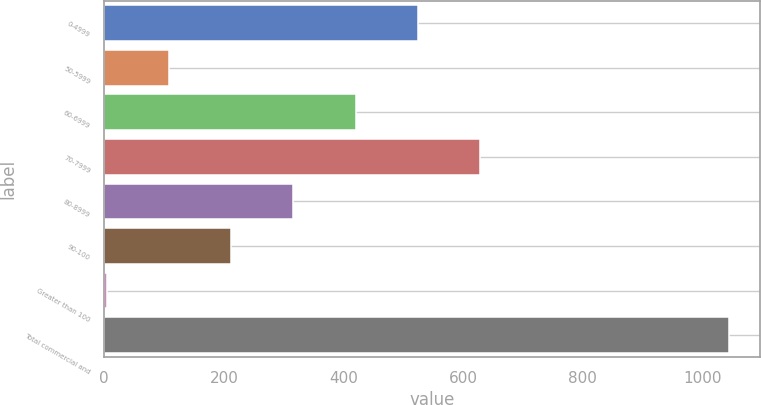Convert chart. <chart><loc_0><loc_0><loc_500><loc_500><bar_chart><fcel>0-4999<fcel>50-5999<fcel>60-6999<fcel>70-7999<fcel>80-8999<fcel>90-100<fcel>Greater than 100<fcel>Total commercial and<nl><fcel>524.2<fcel>108.36<fcel>420.24<fcel>628.16<fcel>316.28<fcel>212.32<fcel>4.4<fcel>1044<nl></chart> 